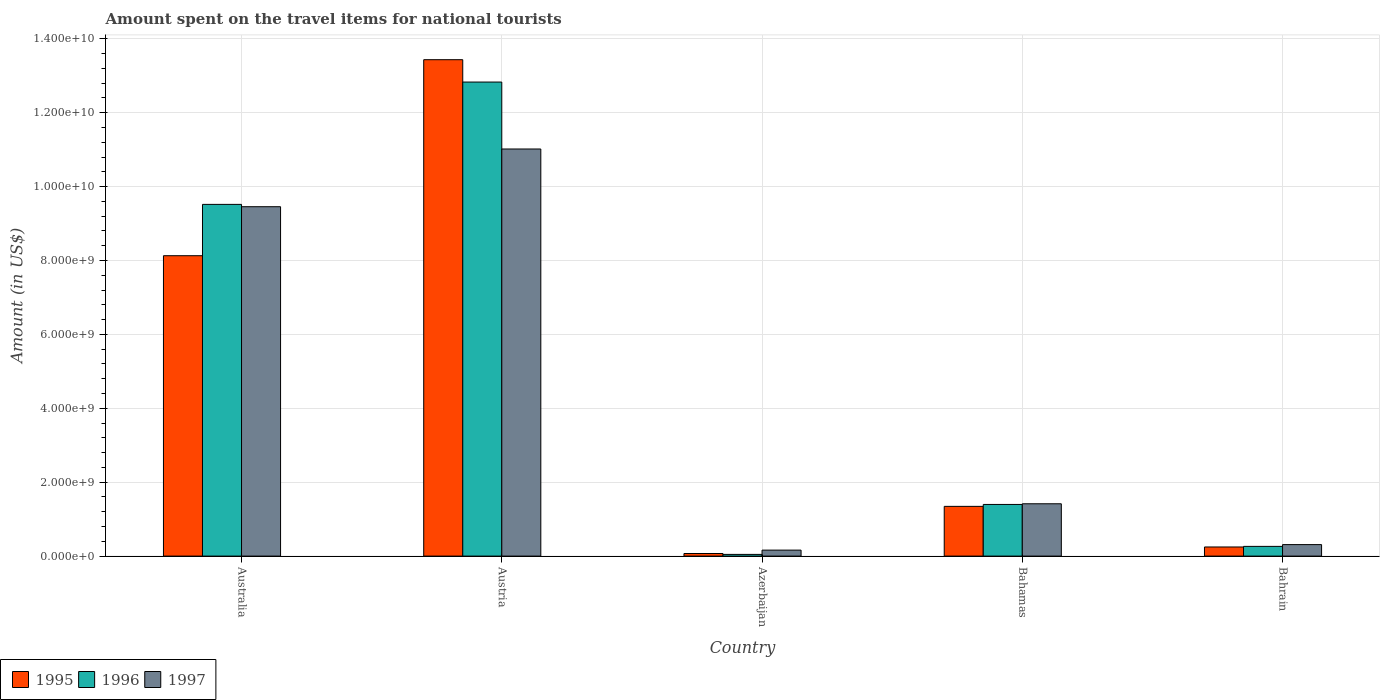Are the number of bars on each tick of the X-axis equal?
Ensure brevity in your answer.  Yes. How many bars are there on the 1st tick from the right?
Provide a succinct answer. 3. What is the amount spent on the travel items for national tourists in 1996 in Australia?
Provide a short and direct response. 9.52e+09. Across all countries, what is the maximum amount spent on the travel items for national tourists in 1995?
Provide a succinct answer. 1.34e+1. Across all countries, what is the minimum amount spent on the travel items for national tourists in 1997?
Offer a very short reply. 1.62e+08. In which country was the amount spent on the travel items for national tourists in 1997 minimum?
Your answer should be very brief. Azerbaijan. What is the total amount spent on the travel items for national tourists in 1996 in the graph?
Your answer should be very brief. 2.41e+1. What is the difference between the amount spent on the travel items for national tourists in 1996 in Australia and that in Bahamas?
Keep it short and to the point. 8.12e+09. What is the difference between the amount spent on the travel items for national tourists in 1995 in Australia and the amount spent on the travel items for national tourists in 1997 in Azerbaijan?
Give a very brief answer. 7.97e+09. What is the average amount spent on the travel items for national tourists in 1995 per country?
Give a very brief answer. 4.65e+09. What is the difference between the amount spent on the travel items for national tourists of/in 1997 and amount spent on the travel items for national tourists of/in 1996 in Bahamas?
Provide a succinct answer. 1.80e+07. In how many countries, is the amount spent on the travel items for national tourists in 1997 greater than 8000000000 US$?
Your answer should be very brief. 2. What is the ratio of the amount spent on the travel items for national tourists in 1996 in Azerbaijan to that in Bahamas?
Make the answer very short. 0.03. Is the difference between the amount spent on the travel items for national tourists in 1997 in Australia and Bahrain greater than the difference between the amount spent on the travel items for national tourists in 1996 in Australia and Bahrain?
Ensure brevity in your answer.  No. What is the difference between the highest and the second highest amount spent on the travel items for national tourists in 1996?
Keep it short and to the point. 1.14e+1. What is the difference between the highest and the lowest amount spent on the travel items for national tourists in 1995?
Your answer should be compact. 1.34e+1. In how many countries, is the amount spent on the travel items for national tourists in 1996 greater than the average amount spent on the travel items for national tourists in 1996 taken over all countries?
Ensure brevity in your answer.  2. Is the sum of the amount spent on the travel items for national tourists in 1996 in Austria and Bahamas greater than the maximum amount spent on the travel items for national tourists in 1997 across all countries?
Give a very brief answer. Yes. What does the 2nd bar from the right in Australia represents?
Provide a short and direct response. 1996. Is it the case that in every country, the sum of the amount spent on the travel items for national tourists in 1996 and amount spent on the travel items for national tourists in 1995 is greater than the amount spent on the travel items for national tourists in 1997?
Your response must be concise. No. Does the graph contain any zero values?
Provide a succinct answer. No. Does the graph contain grids?
Keep it short and to the point. Yes. Where does the legend appear in the graph?
Keep it short and to the point. Bottom left. How many legend labels are there?
Provide a short and direct response. 3. What is the title of the graph?
Keep it short and to the point. Amount spent on the travel items for national tourists. What is the label or title of the X-axis?
Make the answer very short. Country. What is the Amount (in US$) in 1995 in Australia?
Your answer should be compact. 8.13e+09. What is the Amount (in US$) in 1996 in Australia?
Provide a short and direct response. 9.52e+09. What is the Amount (in US$) in 1997 in Australia?
Keep it short and to the point. 9.46e+09. What is the Amount (in US$) in 1995 in Austria?
Offer a terse response. 1.34e+1. What is the Amount (in US$) in 1996 in Austria?
Make the answer very short. 1.28e+1. What is the Amount (in US$) of 1997 in Austria?
Provide a succinct answer. 1.10e+1. What is the Amount (in US$) in 1995 in Azerbaijan?
Make the answer very short. 7.00e+07. What is the Amount (in US$) in 1996 in Azerbaijan?
Your response must be concise. 4.60e+07. What is the Amount (in US$) in 1997 in Azerbaijan?
Ensure brevity in your answer.  1.62e+08. What is the Amount (in US$) of 1995 in Bahamas?
Offer a very short reply. 1.35e+09. What is the Amount (in US$) in 1996 in Bahamas?
Ensure brevity in your answer.  1.40e+09. What is the Amount (in US$) in 1997 in Bahamas?
Your answer should be very brief. 1.42e+09. What is the Amount (in US$) in 1995 in Bahrain?
Provide a short and direct response. 2.47e+08. What is the Amount (in US$) of 1996 in Bahrain?
Provide a succinct answer. 2.63e+08. What is the Amount (in US$) of 1997 in Bahrain?
Provide a succinct answer. 3.11e+08. Across all countries, what is the maximum Amount (in US$) in 1995?
Offer a very short reply. 1.34e+1. Across all countries, what is the maximum Amount (in US$) of 1996?
Offer a very short reply. 1.28e+1. Across all countries, what is the maximum Amount (in US$) of 1997?
Make the answer very short. 1.10e+1. Across all countries, what is the minimum Amount (in US$) of 1995?
Offer a terse response. 7.00e+07. Across all countries, what is the minimum Amount (in US$) in 1996?
Your answer should be very brief. 4.60e+07. Across all countries, what is the minimum Amount (in US$) of 1997?
Keep it short and to the point. 1.62e+08. What is the total Amount (in US$) of 1995 in the graph?
Give a very brief answer. 2.32e+1. What is the total Amount (in US$) in 1996 in the graph?
Your answer should be compact. 2.41e+1. What is the total Amount (in US$) in 1997 in the graph?
Your answer should be very brief. 2.24e+1. What is the difference between the Amount (in US$) in 1995 in Australia and that in Austria?
Provide a short and direct response. -5.30e+09. What is the difference between the Amount (in US$) of 1996 in Australia and that in Austria?
Give a very brief answer. -3.31e+09. What is the difference between the Amount (in US$) of 1997 in Australia and that in Austria?
Your answer should be very brief. -1.56e+09. What is the difference between the Amount (in US$) of 1995 in Australia and that in Azerbaijan?
Offer a very short reply. 8.06e+09. What is the difference between the Amount (in US$) of 1996 in Australia and that in Azerbaijan?
Your response must be concise. 9.47e+09. What is the difference between the Amount (in US$) of 1997 in Australia and that in Azerbaijan?
Make the answer very short. 9.29e+09. What is the difference between the Amount (in US$) in 1995 in Australia and that in Bahamas?
Ensure brevity in your answer.  6.78e+09. What is the difference between the Amount (in US$) in 1996 in Australia and that in Bahamas?
Ensure brevity in your answer.  8.12e+09. What is the difference between the Amount (in US$) of 1997 in Australia and that in Bahamas?
Provide a succinct answer. 8.04e+09. What is the difference between the Amount (in US$) of 1995 in Australia and that in Bahrain?
Offer a terse response. 7.88e+09. What is the difference between the Amount (in US$) in 1996 in Australia and that in Bahrain?
Keep it short and to the point. 9.26e+09. What is the difference between the Amount (in US$) in 1997 in Australia and that in Bahrain?
Provide a succinct answer. 9.14e+09. What is the difference between the Amount (in US$) of 1995 in Austria and that in Azerbaijan?
Your answer should be compact. 1.34e+1. What is the difference between the Amount (in US$) of 1996 in Austria and that in Azerbaijan?
Make the answer very short. 1.28e+1. What is the difference between the Amount (in US$) in 1997 in Austria and that in Azerbaijan?
Make the answer very short. 1.09e+1. What is the difference between the Amount (in US$) of 1995 in Austria and that in Bahamas?
Keep it short and to the point. 1.21e+1. What is the difference between the Amount (in US$) of 1996 in Austria and that in Bahamas?
Give a very brief answer. 1.14e+1. What is the difference between the Amount (in US$) in 1997 in Austria and that in Bahamas?
Your answer should be very brief. 9.60e+09. What is the difference between the Amount (in US$) in 1995 in Austria and that in Bahrain?
Provide a short and direct response. 1.32e+1. What is the difference between the Amount (in US$) of 1996 in Austria and that in Bahrain?
Your answer should be compact. 1.26e+1. What is the difference between the Amount (in US$) of 1997 in Austria and that in Bahrain?
Keep it short and to the point. 1.07e+1. What is the difference between the Amount (in US$) of 1995 in Azerbaijan and that in Bahamas?
Provide a short and direct response. -1.28e+09. What is the difference between the Amount (in US$) in 1996 in Azerbaijan and that in Bahamas?
Give a very brief answer. -1.35e+09. What is the difference between the Amount (in US$) of 1997 in Azerbaijan and that in Bahamas?
Provide a short and direct response. -1.25e+09. What is the difference between the Amount (in US$) of 1995 in Azerbaijan and that in Bahrain?
Ensure brevity in your answer.  -1.77e+08. What is the difference between the Amount (in US$) of 1996 in Azerbaijan and that in Bahrain?
Ensure brevity in your answer.  -2.17e+08. What is the difference between the Amount (in US$) in 1997 in Azerbaijan and that in Bahrain?
Make the answer very short. -1.49e+08. What is the difference between the Amount (in US$) of 1995 in Bahamas and that in Bahrain?
Ensure brevity in your answer.  1.10e+09. What is the difference between the Amount (in US$) in 1996 in Bahamas and that in Bahrain?
Keep it short and to the point. 1.14e+09. What is the difference between the Amount (in US$) in 1997 in Bahamas and that in Bahrain?
Your answer should be very brief. 1.10e+09. What is the difference between the Amount (in US$) in 1995 in Australia and the Amount (in US$) in 1996 in Austria?
Provide a succinct answer. -4.70e+09. What is the difference between the Amount (in US$) in 1995 in Australia and the Amount (in US$) in 1997 in Austria?
Make the answer very short. -2.89e+09. What is the difference between the Amount (in US$) in 1996 in Australia and the Amount (in US$) in 1997 in Austria?
Make the answer very short. -1.50e+09. What is the difference between the Amount (in US$) of 1995 in Australia and the Amount (in US$) of 1996 in Azerbaijan?
Your answer should be compact. 8.08e+09. What is the difference between the Amount (in US$) in 1995 in Australia and the Amount (in US$) in 1997 in Azerbaijan?
Give a very brief answer. 7.97e+09. What is the difference between the Amount (in US$) of 1996 in Australia and the Amount (in US$) of 1997 in Azerbaijan?
Your answer should be compact. 9.36e+09. What is the difference between the Amount (in US$) of 1995 in Australia and the Amount (in US$) of 1996 in Bahamas?
Make the answer very short. 6.73e+09. What is the difference between the Amount (in US$) in 1995 in Australia and the Amount (in US$) in 1997 in Bahamas?
Your answer should be compact. 6.71e+09. What is the difference between the Amount (in US$) in 1996 in Australia and the Amount (in US$) in 1997 in Bahamas?
Provide a short and direct response. 8.10e+09. What is the difference between the Amount (in US$) of 1995 in Australia and the Amount (in US$) of 1996 in Bahrain?
Provide a short and direct response. 7.87e+09. What is the difference between the Amount (in US$) in 1995 in Australia and the Amount (in US$) in 1997 in Bahrain?
Offer a very short reply. 7.82e+09. What is the difference between the Amount (in US$) of 1996 in Australia and the Amount (in US$) of 1997 in Bahrain?
Keep it short and to the point. 9.21e+09. What is the difference between the Amount (in US$) of 1995 in Austria and the Amount (in US$) of 1996 in Azerbaijan?
Provide a succinct answer. 1.34e+1. What is the difference between the Amount (in US$) in 1995 in Austria and the Amount (in US$) in 1997 in Azerbaijan?
Give a very brief answer. 1.33e+1. What is the difference between the Amount (in US$) of 1996 in Austria and the Amount (in US$) of 1997 in Azerbaijan?
Your answer should be compact. 1.27e+1. What is the difference between the Amount (in US$) of 1995 in Austria and the Amount (in US$) of 1996 in Bahamas?
Ensure brevity in your answer.  1.20e+1. What is the difference between the Amount (in US$) in 1995 in Austria and the Amount (in US$) in 1997 in Bahamas?
Your answer should be very brief. 1.20e+1. What is the difference between the Amount (in US$) of 1996 in Austria and the Amount (in US$) of 1997 in Bahamas?
Provide a short and direct response. 1.14e+1. What is the difference between the Amount (in US$) in 1995 in Austria and the Amount (in US$) in 1996 in Bahrain?
Ensure brevity in your answer.  1.32e+1. What is the difference between the Amount (in US$) of 1995 in Austria and the Amount (in US$) of 1997 in Bahrain?
Your answer should be very brief. 1.31e+1. What is the difference between the Amount (in US$) of 1996 in Austria and the Amount (in US$) of 1997 in Bahrain?
Provide a short and direct response. 1.25e+1. What is the difference between the Amount (in US$) of 1995 in Azerbaijan and the Amount (in US$) of 1996 in Bahamas?
Make the answer very short. -1.33e+09. What is the difference between the Amount (in US$) of 1995 in Azerbaijan and the Amount (in US$) of 1997 in Bahamas?
Offer a very short reply. -1.35e+09. What is the difference between the Amount (in US$) in 1996 in Azerbaijan and the Amount (in US$) in 1997 in Bahamas?
Ensure brevity in your answer.  -1.37e+09. What is the difference between the Amount (in US$) of 1995 in Azerbaijan and the Amount (in US$) of 1996 in Bahrain?
Ensure brevity in your answer.  -1.93e+08. What is the difference between the Amount (in US$) of 1995 in Azerbaijan and the Amount (in US$) of 1997 in Bahrain?
Your answer should be very brief. -2.41e+08. What is the difference between the Amount (in US$) in 1996 in Azerbaijan and the Amount (in US$) in 1997 in Bahrain?
Give a very brief answer. -2.65e+08. What is the difference between the Amount (in US$) in 1995 in Bahamas and the Amount (in US$) in 1996 in Bahrain?
Your answer should be very brief. 1.08e+09. What is the difference between the Amount (in US$) of 1995 in Bahamas and the Amount (in US$) of 1997 in Bahrain?
Your answer should be compact. 1.04e+09. What is the difference between the Amount (in US$) of 1996 in Bahamas and the Amount (in US$) of 1997 in Bahrain?
Keep it short and to the point. 1.09e+09. What is the average Amount (in US$) in 1995 per country?
Provide a succinct answer. 4.65e+09. What is the average Amount (in US$) in 1996 per country?
Offer a very short reply. 4.81e+09. What is the average Amount (in US$) of 1997 per country?
Offer a terse response. 4.47e+09. What is the difference between the Amount (in US$) of 1995 and Amount (in US$) of 1996 in Australia?
Ensure brevity in your answer.  -1.39e+09. What is the difference between the Amount (in US$) of 1995 and Amount (in US$) of 1997 in Australia?
Provide a short and direct response. -1.33e+09. What is the difference between the Amount (in US$) in 1996 and Amount (in US$) in 1997 in Australia?
Provide a short and direct response. 6.30e+07. What is the difference between the Amount (in US$) of 1995 and Amount (in US$) of 1996 in Austria?
Provide a succinct answer. 6.05e+08. What is the difference between the Amount (in US$) in 1995 and Amount (in US$) in 1997 in Austria?
Offer a very short reply. 2.42e+09. What is the difference between the Amount (in US$) in 1996 and Amount (in US$) in 1997 in Austria?
Keep it short and to the point. 1.81e+09. What is the difference between the Amount (in US$) in 1995 and Amount (in US$) in 1996 in Azerbaijan?
Ensure brevity in your answer.  2.40e+07. What is the difference between the Amount (in US$) in 1995 and Amount (in US$) in 1997 in Azerbaijan?
Keep it short and to the point. -9.20e+07. What is the difference between the Amount (in US$) in 1996 and Amount (in US$) in 1997 in Azerbaijan?
Make the answer very short. -1.16e+08. What is the difference between the Amount (in US$) in 1995 and Amount (in US$) in 1996 in Bahamas?
Your response must be concise. -5.20e+07. What is the difference between the Amount (in US$) of 1995 and Amount (in US$) of 1997 in Bahamas?
Ensure brevity in your answer.  -7.00e+07. What is the difference between the Amount (in US$) in 1996 and Amount (in US$) in 1997 in Bahamas?
Keep it short and to the point. -1.80e+07. What is the difference between the Amount (in US$) in 1995 and Amount (in US$) in 1996 in Bahrain?
Give a very brief answer. -1.60e+07. What is the difference between the Amount (in US$) of 1995 and Amount (in US$) of 1997 in Bahrain?
Provide a succinct answer. -6.40e+07. What is the difference between the Amount (in US$) in 1996 and Amount (in US$) in 1997 in Bahrain?
Provide a short and direct response. -4.80e+07. What is the ratio of the Amount (in US$) of 1995 in Australia to that in Austria?
Make the answer very short. 0.61. What is the ratio of the Amount (in US$) in 1996 in Australia to that in Austria?
Provide a succinct answer. 0.74. What is the ratio of the Amount (in US$) in 1997 in Australia to that in Austria?
Your answer should be very brief. 0.86. What is the ratio of the Amount (in US$) of 1995 in Australia to that in Azerbaijan?
Offer a terse response. 116.14. What is the ratio of the Amount (in US$) in 1996 in Australia to that in Azerbaijan?
Give a very brief answer. 206.93. What is the ratio of the Amount (in US$) in 1997 in Australia to that in Azerbaijan?
Keep it short and to the point. 58.37. What is the ratio of the Amount (in US$) of 1995 in Australia to that in Bahamas?
Your answer should be compact. 6.04. What is the ratio of the Amount (in US$) of 1996 in Australia to that in Bahamas?
Make the answer very short. 6.81. What is the ratio of the Amount (in US$) in 1997 in Australia to that in Bahamas?
Ensure brevity in your answer.  6.68. What is the ratio of the Amount (in US$) of 1995 in Australia to that in Bahrain?
Provide a short and direct response. 32.91. What is the ratio of the Amount (in US$) of 1996 in Australia to that in Bahrain?
Your response must be concise. 36.19. What is the ratio of the Amount (in US$) of 1997 in Australia to that in Bahrain?
Offer a terse response. 30.41. What is the ratio of the Amount (in US$) of 1995 in Austria to that in Azerbaijan?
Your response must be concise. 191.93. What is the ratio of the Amount (in US$) in 1996 in Austria to that in Azerbaijan?
Your answer should be very brief. 278.91. What is the ratio of the Amount (in US$) in 1997 in Austria to that in Azerbaijan?
Your response must be concise. 68.01. What is the ratio of the Amount (in US$) in 1995 in Austria to that in Bahamas?
Make the answer very short. 9.98. What is the ratio of the Amount (in US$) in 1996 in Austria to that in Bahamas?
Provide a succinct answer. 9.18. What is the ratio of the Amount (in US$) in 1997 in Austria to that in Bahamas?
Ensure brevity in your answer.  7.78. What is the ratio of the Amount (in US$) of 1995 in Austria to that in Bahrain?
Provide a succinct answer. 54.39. What is the ratio of the Amount (in US$) in 1996 in Austria to that in Bahrain?
Offer a very short reply. 48.78. What is the ratio of the Amount (in US$) of 1997 in Austria to that in Bahrain?
Provide a short and direct response. 35.43. What is the ratio of the Amount (in US$) in 1995 in Azerbaijan to that in Bahamas?
Provide a short and direct response. 0.05. What is the ratio of the Amount (in US$) in 1996 in Azerbaijan to that in Bahamas?
Provide a succinct answer. 0.03. What is the ratio of the Amount (in US$) in 1997 in Azerbaijan to that in Bahamas?
Give a very brief answer. 0.11. What is the ratio of the Amount (in US$) in 1995 in Azerbaijan to that in Bahrain?
Make the answer very short. 0.28. What is the ratio of the Amount (in US$) of 1996 in Azerbaijan to that in Bahrain?
Your response must be concise. 0.17. What is the ratio of the Amount (in US$) of 1997 in Azerbaijan to that in Bahrain?
Give a very brief answer. 0.52. What is the ratio of the Amount (in US$) in 1995 in Bahamas to that in Bahrain?
Offer a terse response. 5.45. What is the ratio of the Amount (in US$) in 1996 in Bahamas to that in Bahrain?
Provide a succinct answer. 5.32. What is the ratio of the Amount (in US$) in 1997 in Bahamas to that in Bahrain?
Your response must be concise. 4.55. What is the difference between the highest and the second highest Amount (in US$) in 1995?
Offer a very short reply. 5.30e+09. What is the difference between the highest and the second highest Amount (in US$) in 1996?
Keep it short and to the point. 3.31e+09. What is the difference between the highest and the second highest Amount (in US$) of 1997?
Make the answer very short. 1.56e+09. What is the difference between the highest and the lowest Amount (in US$) in 1995?
Keep it short and to the point. 1.34e+1. What is the difference between the highest and the lowest Amount (in US$) in 1996?
Your response must be concise. 1.28e+1. What is the difference between the highest and the lowest Amount (in US$) of 1997?
Provide a short and direct response. 1.09e+1. 